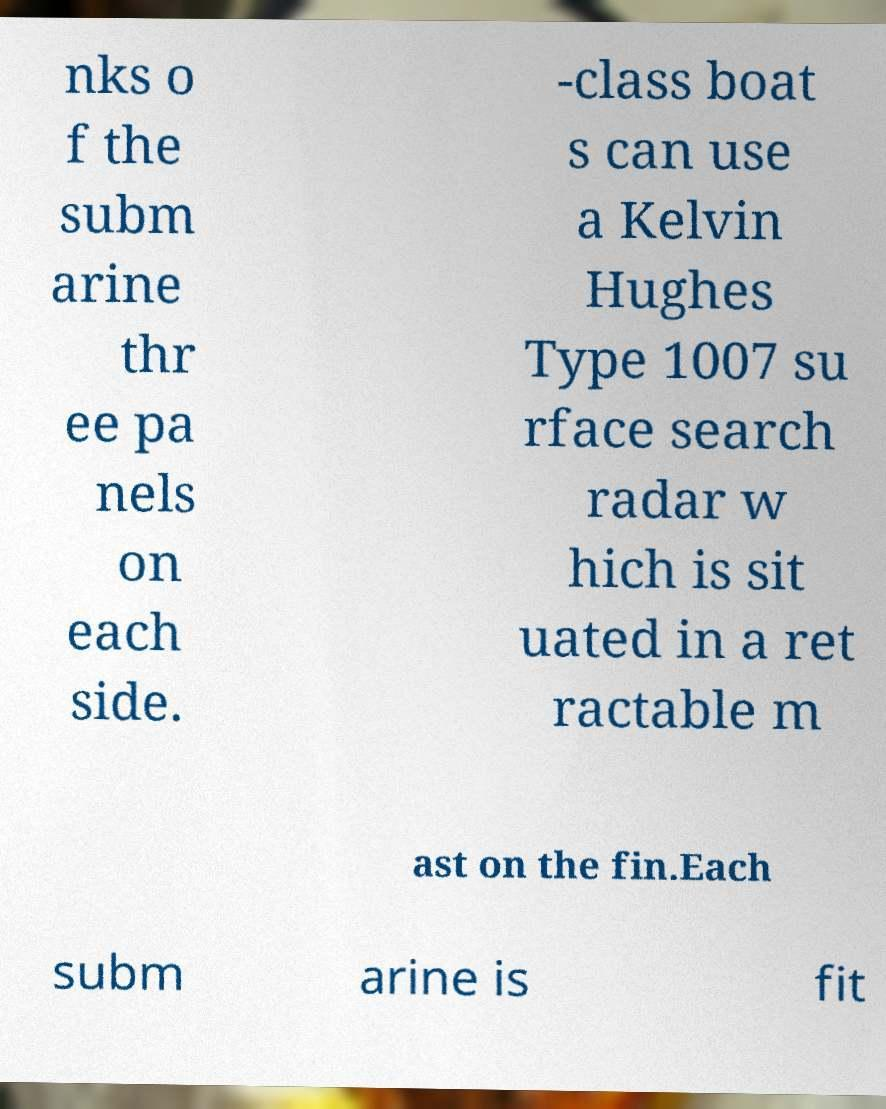For documentation purposes, I need the text within this image transcribed. Could you provide that? nks o f the subm arine thr ee pa nels on each side. -class boat s can use a Kelvin Hughes Type 1007 su rface search radar w hich is sit uated in a ret ractable m ast on the fin.Each subm arine is fit 